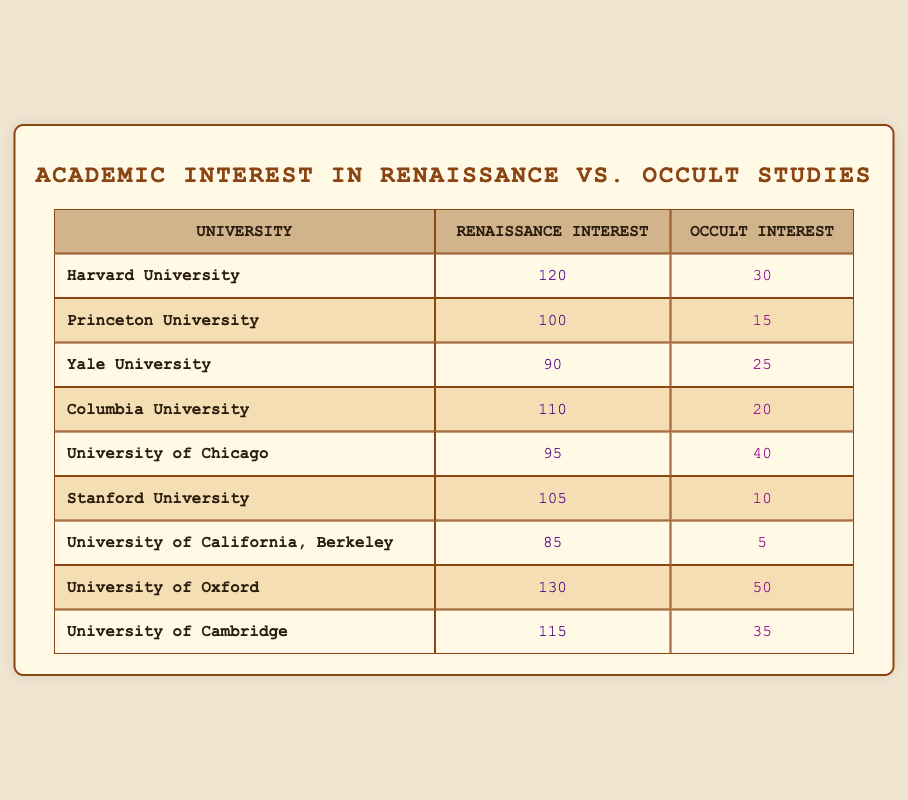What is the total interest in Renaissance studies among all universities? To find the total interest in Renaissance studies, we sum the values for each university: 120 + 100 + 90 + 110 + 95 + 105 + 85 + 130 + 115 = 1,010.
Answer: 1,010 Which university has the highest interest in occult studies? By looking at the values in the "Occult Interest" column, we find that the University of Oxford has the highest interest with a value of 50.
Answer: University of Oxford Is the interest in occult studies higher at the University of Chicago than at Columbia University? For the University of Chicago, the interest is 40, while for Columbia University, it is 20. Since 40 is greater than 20, the interest at the University of Chicago is higher.
Answer: Yes What is the average interest in Renaissance studies across all universities? To calculate the average, we first find the total interest in Renaissance studies, which is 1,010, and then divide by the number of universities, which is 9. So, the average is 1,010 / 9 ≈ 112.22.
Answer: Approximately 112.22 Which university has the lowest interest in occult studies? By checking the values in the "Occult Interest" column, we see that the University of California, Berkeley has the lowest interest with a value of 5.
Answer: University of California, Berkeley How many universities have an interest in Renaissance studies above 100? The universities with Renaissance interest above 100 are Harvard (120), Princeton (100), Columbia (110), Oxford (130), and Cambridge (115), totaling 5 universities.
Answer: 5 Is the total interest in occult studies across all universities greater than that of Renaissance studies? The total interest in occult studies is 30 + 15 + 25 + 20 + 40 + 10 + 5 + 50 + 35 = 230, which is less than the total interest in Renaissance studies (1,010).
Answer: No What is the difference between the highest and lowest interest in Renaissance studies? The highest interest is from the University of Oxford (130), while the lowest is from the University of California, Berkeley (85). The difference is 130 - 85 = 45.
Answer: 45 